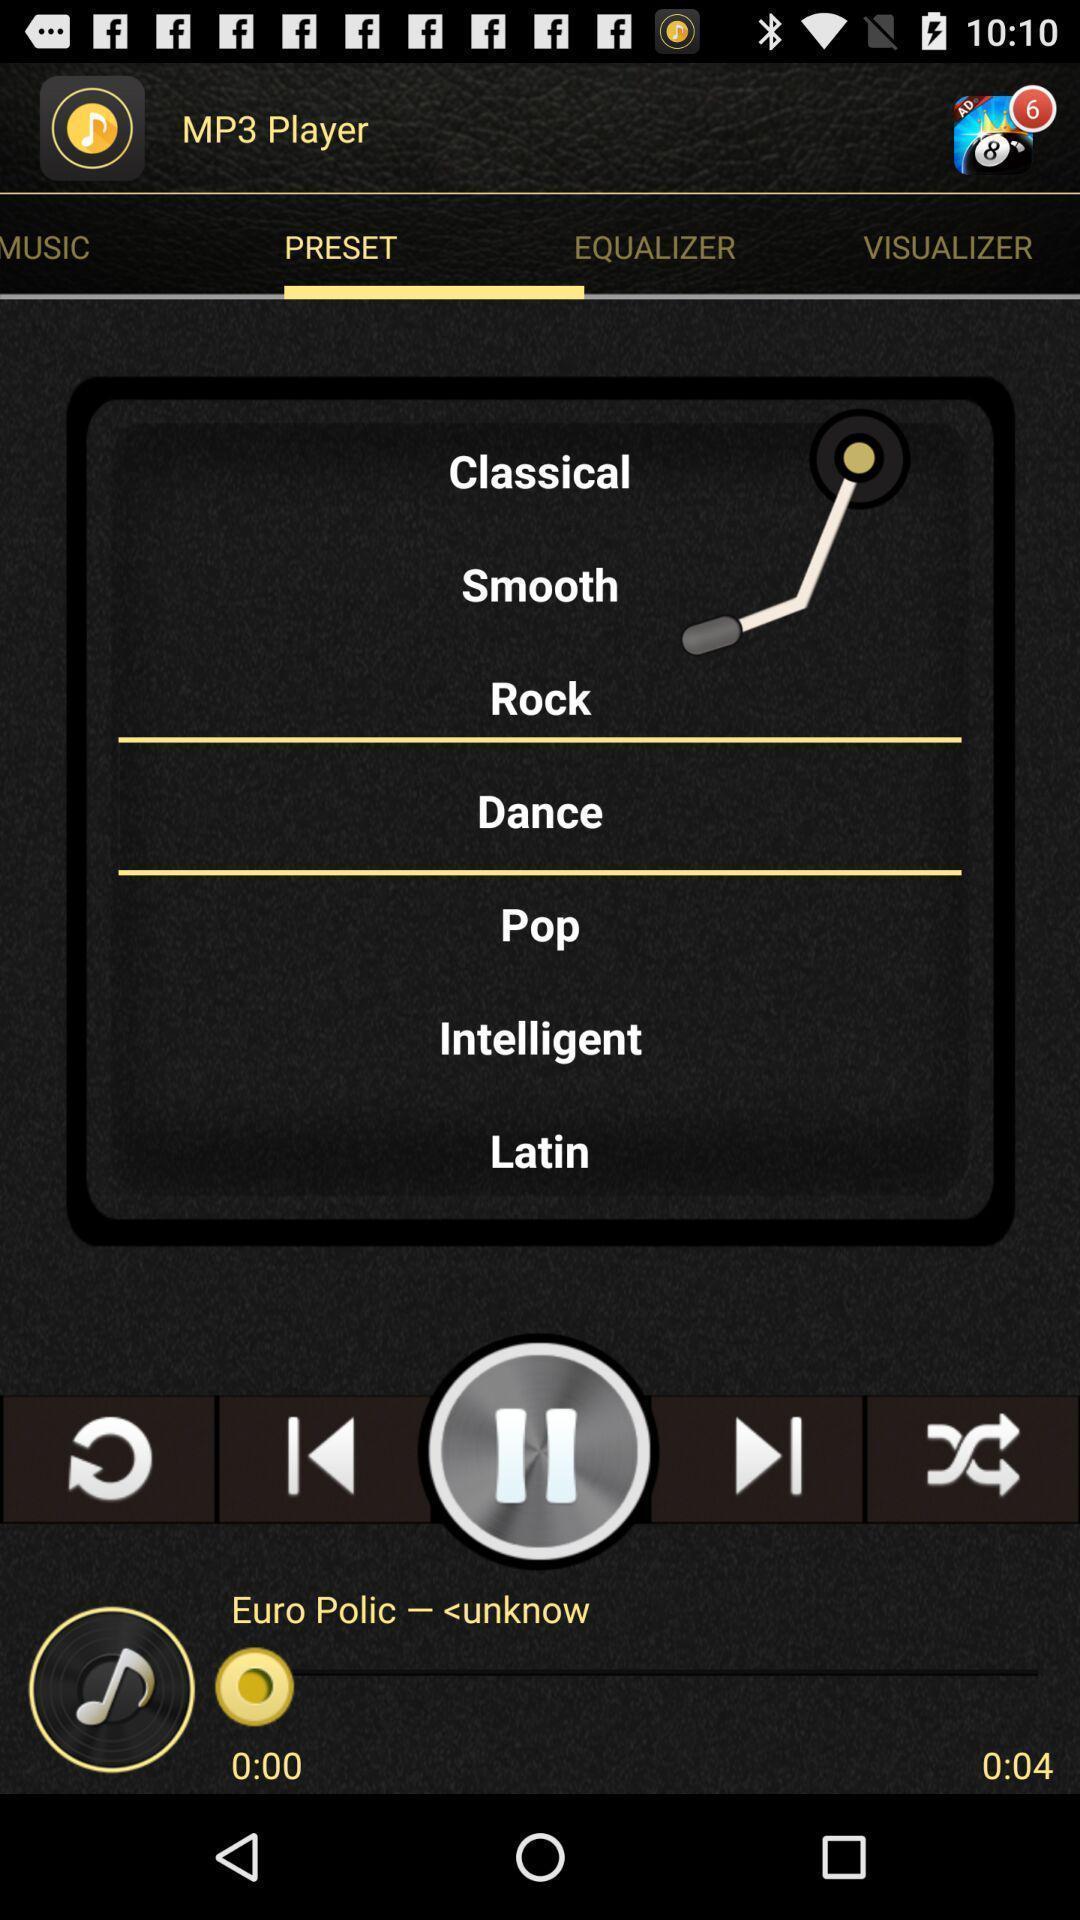Summarize the information in this screenshot. Screen displaying the tuner settings in music app. 